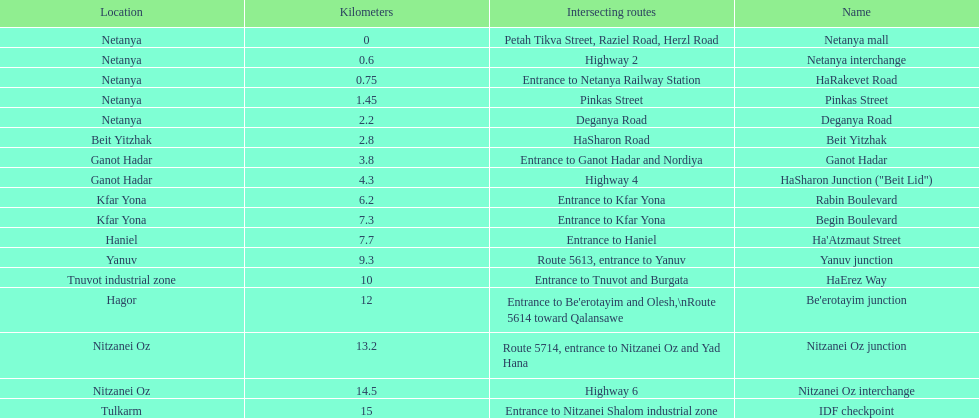Which section is longest?? IDF checkpoint. 